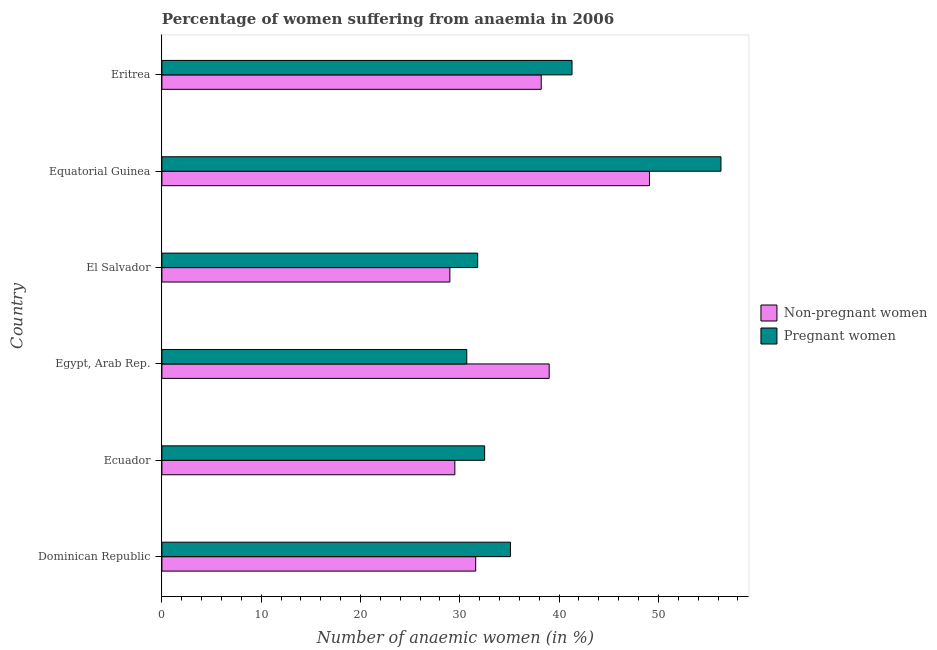How many groups of bars are there?
Provide a short and direct response. 6. How many bars are there on the 4th tick from the top?
Provide a succinct answer. 2. What is the label of the 4th group of bars from the top?
Give a very brief answer. Egypt, Arab Rep. What is the percentage of pregnant anaemic women in Eritrea?
Your response must be concise. 41.3. Across all countries, what is the maximum percentage of non-pregnant anaemic women?
Offer a terse response. 49.1. In which country was the percentage of pregnant anaemic women maximum?
Your answer should be very brief. Equatorial Guinea. In which country was the percentage of pregnant anaemic women minimum?
Provide a short and direct response. Egypt, Arab Rep. What is the total percentage of pregnant anaemic women in the graph?
Ensure brevity in your answer.  227.7. What is the difference between the percentage of pregnant anaemic women in Dominican Republic and that in Egypt, Arab Rep.?
Make the answer very short. 4.4. What is the difference between the percentage of pregnant anaemic women in Ecuador and the percentage of non-pregnant anaemic women in Dominican Republic?
Offer a very short reply. 0.9. What is the average percentage of pregnant anaemic women per country?
Ensure brevity in your answer.  37.95. In how many countries, is the percentage of non-pregnant anaemic women greater than 20 %?
Provide a succinct answer. 6. What is the ratio of the percentage of non-pregnant anaemic women in Ecuador to that in Egypt, Arab Rep.?
Your answer should be very brief. 0.76. Is the percentage of non-pregnant anaemic women in Equatorial Guinea less than that in Eritrea?
Provide a succinct answer. No. Is the difference between the percentage of non-pregnant anaemic women in Egypt, Arab Rep. and Eritrea greater than the difference between the percentage of pregnant anaemic women in Egypt, Arab Rep. and Eritrea?
Provide a succinct answer. Yes. What is the difference between the highest and the second highest percentage of non-pregnant anaemic women?
Provide a succinct answer. 10.1. What is the difference between the highest and the lowest percentage of pregnant anaemic women?
Make the answer very short. 25.6. In how many countries, is the percentage of pregnant anaemic women greater than the average percentage of pregnant anaemic women taken over all countries?
Offer a very short reply. 2. Is the sum of the percentage of pregnant anaemic women in Egypt, Arab Rep. and Equatorial Guinea greater than the maximum percentage of non-pregnant anaemic women across all countries?
Offer a very short reply. Yes. What does the 1st bar from the top in Egypt, Arab Rep. represents?
Provide a short and direct response. Pregnant women. What does the 1st bar from the bottom in El Salvador represents?
Your response must be concise. Non-pregnant women. How many countries are there in the graph?
Provide a short and direct response. 6. What is the difference between two consecutive major ticks on the X-axis?
Your response must be concise. 10. Does the graph contain any zero values?
Provide a short and direct response. No. Does the graph contain grids?
Give a very brief answer. No. What is the title of the graph?
Offer a terse response. Percentage of women suffering from anaemia in 2006. Does "Health Care" appear as one of the legend labels in the graph?
Keep it short and to the point. No. What is the label or title of the X-axis?
Offer a terse response. Number of anaemic women (in %). What is the label or title of the Y-axis?
Your answer should be compact. Country. What is the Number of anaemic women (in %) in Non-pregnant women in Dominican Republic?
Provide a succinct answer. 31.6. What is the Number of anaemic women (in %) in Pregnant women in Dominican Republic?
Your answer should be very brief. 35.1. What is the Number of anaemic women (in %) of Non-pregnant women in Ecuador?
Make the answer very short. 29.5. What is the Number of anaemic women (in %) of Pregnant women in Ecuador?
Ensure brevity in your answer.  32.5. What is the Number of anaemic women (in %) of Pregnant women in Egypt, Arab Rep.?
Your answer should be very brief. 30.7. What is the Number of anaemic women (in %) in Pregnant women in El Salvador?
Provide a short and direct response. 31.8. What is the Number of anaemic women (in %) in Non-pregnant women in Equatorial Guinea?
Your answer should be compact. 49.1. What is the Number of anaemic women (in %) of Pregnant women in Equatorial Guinea?
Ensure brevity in your answer.  56.3. What is the Number of anaemic women (in %) of Non-pregnant women in Eritrea?
Offer a very short reply. 38.2. What is the Number of anaemic women (in %) of Pregnant women in Eritrea?
Offer a very short reply. 41.3. Across all countries, what is the maximum Number of anaemic women (in %) of Non-pregnant women?
Offer a very short reply. 49.1. Across all countries, what is the maximum Number of anaemic women (in %) in Pregnant women?
Offer a terse response. 56.3. Across all countries, what is the minimum Number of anaemic women (in %) in Pregnant women?
Ensure brevity in your answer.  30.7. What is the total Number of anaemic women (in %) in Non-pregnant women in the graph?
Offer a very short reply. 216.4. What is the total Number of anaemic women (in %) of Pregnant women in the graph?
Provide a succinct answer. 227.7. What is the difference between the Number of anaemic women (in %) of Pregnant women in Dominican Republic and that in Egypt, Arab Rep.?
Provide a succinct answer. 4.4. What is the difference between the Number of anaemic women (in %) of Non-pregnant women in Dominican Republic and that in Equatorial Guinea?
Your answer should be very brief. -17.5. What is the difference between the Number of anaemic women (in %) in Pregnant women in Dominican Republic and that in Equatorial Guinea?
Keep it short and to the point. -21.2. What is the difference between the Number of anaemic women (in %) of Pregnant women in Dominican Republic and that in Eritrea?
Keep it short and to the point. -6.2. What is the difference between the Number of anaemic women (in %) of Non-pregnant women in Ecuador and that in El Salvador?
Offer a very short reply. 0.5. What is the difference between the Number of anaemic women (in %) of Pregnant women in Ecuador and that in El Salvador?
Give a very brief answer. 0.7. What is the difference between the Number of anaemic women (in %) in Non-pregnant women in Ecuador and that in Equatorial Guinea?
Provide a succinct answer. -19.6. What is the difference between the Number of anaemic women (in %) of Pregnant women in Ecuador and that in Equatorial Guinea?
Keep it short and to the point. -23.8. What is the difference between the Number of anaemic women (in %) of Non-pregnant women in Ecuador and that in Eritrea?
Your response must be concise. -8.7. What is the difference between the Number of anaemic women (in %) of Pregnant women in Ecuador and that in Eritrea?
Offer a terse response. -8.8. What is the difference between the Number of anaemic women (in %) of Non-pregnant women in Egypt, Arab Rep. and that in El Salvador?
Make the answer very short. 10. What is the difference between the Number of anaemic women (in %) in Pregnant women in Egypt, Arab Rep. and that in Equatorial Guinea?
Give a very brief answer. -25.6. What is the difference between the Number of anaemic women (in %) of Non-pregnant women in Egypt, Arab Rep. and that in Eritrea?
Give a very brief answer. 0.8. What is the difference between the Number of anaemic women (in %) of Non-pregnant women in El Salvador and that in Equatorial Guinea?
Offer a terse response. -20.1. What is the difference between the Number of anaemic women (in %) of Pregnant women in El Salvador and that in Equatorial Guinea?
Make the answer very short. -24.5. What is the difference between the Number of anaemic women (in %) of Non-pregnant women in El Salvador and that in Eritrea?
Keep it short and to the point. -9.2. What is the difference between the Number of anaemic women (in %) of Pregnant women in El Salvador and that in Eritrea?
Your answer should be very brief. -9.5. What is the difference between the Number of anaemic women (in %) of Pregnant women in Equatorial Guinea and that in Eritrea?
Make the answer very short. 15. What is the difference between the Number of anaemic women (in %) of Non-pregnant women in Dominican Republic and the Number of anaemic women (in %) of Pregnant women in Egypt, Arab Rep.?
Your response must be concise. 0.9. What is the difference between the Number of anaemic women (in %) in Non-pregnant women in Dominican Republic and the Number of anaemic women (in %) in Pregnant women in El Salvador?
Ensure brevity in your answer.  -0.2. What is the difference between the Number of anaemic women (in %) of Non-pregnant women in Dominican Republic and the Number of anaemic women (in %) of Pregnant women in Equatorial Guinea?
Offer a terse response. -24.7. What is the difference between the Number of anaemic women (in %) in Non-pregnant women in Ecuador and the Number of anaemic women (in %) in Pregnant women in Egypt, Arab Rep.?
Your response must be concise. -1.2. What is the difference between the Number of anaemic women (in %) of Non-pregnant women in Ecuador and the Number of anaemic women (in %) of Pregnant women in Equatorial Guinea?
Your answer should be compact. -26.8. What is the difference between the Number of anaemic women (in %) in Non-pregnant women in Egypt, Arab Rep. and the Number of anaemic women (in %) in Pregnant women in El Salvador?
Offer a very short reply. 7.2. What is the difference between the Number of anaemic women (in %) in Non-pregnant women in Egypt, Arab Rep. and the Number of anaemic women (in %) in Pregnant women in Equatorial Guinea?
Provide a short and direct response. -17.3. What is the difference between the Number of anaemic women (in %) in Non-pregnant women in Egypt, Arab Rep. and the Number of anaemic women (in %) in Pregnant women in Eritrea?
Provide a succinct answer. -2.3. What is the difference between the Number of anaemic women (in %) of Non-pregnant women in El Salvador and the Number of anaemic women (in %) of Pregnant women in Equatorial Guinea?
Your answer should be compact. -27.3. What is the average Number of anaemic women (in %) in Non-pregnant women per country?
Keep it short and to the point. 36.07. What is the average Number of anaemic women (in %) of Pregnant women per country?
Your answer should be very brief. 37.95. What is the difference between the Number of anaemic women (in %) in Non-pregnant women and Number of anaemic women (in %) in Pregnant women in Dominican Republic?
Keep it short and to the point. -3.5. What is the difference between the Number of anaemic women (in %) in Non-pregnant women and Number of anaemic women (in %) in Pregnant women in El Salvador?
Offer a terse response. -2.8. What is the difference between the Number of anaemic women (in %) in Non-pregnant women and Number of anaemic women (in %) in Pregnant women in Equatorial Guinea?
Your response must be concise. -7.2. What is the difference between the Number of anaemic women (in %) of Non-pregnant women and Number of anaemic women (in %) of Pregnant women in Eritrea?
Your response must be concise. -3.1. What is the ratio of the Number of anaemic women (in %) in Non-pregnant women in Dominican Republic to that in Ecuador?
Provide a succinct answer. 1.07. What is the ratio of the Number of anaemic women (in %) in Pregnant women in Dominican Republic to that in Ecuador?
Offer a terse response. 1.08. What is the ratio of the Number of anaemic women (in %) in Non-pregnant women in Dominican Republic to that in Egypt, Arab Rep.?
Offer a very short reply. 0.81. What is the ratio of the Number of anaemic women (in %) in Pregnant women in Dominican Republic to that in Egypt, Arab Rep.?
Offer a terse response. 1.14. What is the ratio of the Number of anaemic women (in %) of Non-pregnant women in Dominican Republic to that in El Salvador?
Your response must be concise. 1.09. What is the ratio of the Number of anaemic women (in %) in Pregnant women in Dominican Republic to that in El Salvador?
Your answer should be very brief. 1.1. What is the ratio of the Number of anaemic women (in %) of Non-pregnant women in Dominican Republic to that in Equatorial Guinea?
Your response must be concise. 0.64. What is the ratio of the Number of anaemic women (in %) in Pregnant women in Dominican Republic to that in Equatorial Guinea?
Your response must be concise. 0.62. What is the ratio of the Number of anaemic women (in %) of Non-pregnant women in Dominican Republic to that in Eritrea?
Give a very brief answer. 0.83. What is the ratio of the Number of anaemic women (in %) in Pregnant women in Dominican Republic to that in Eritrea?
Your answer should be very brief. 0.85. What is the ratio of the Number of anaemic women (in %) in Non-pregnant women in Ecuador to that in Egypt, Arab Rep.?
Offer a very short reply. 0.76. What is the ratio of the Number of anaemic women (in %) in Pregnant women in Ecuador to that in Egypt, Arab Rep.?
Ensure brevity in your answer.  1.06. What is the ratio of the Number of anaemic women (in %) of Non-pregnant women in Ecuador to that in El Salvador?
Offer a very short reply. 1.02. What is the ratio of the Number of anaemic women (in %) in Non-pregnant women in Ecuador to that in Equatorial Guinea?
Ensure brevity in your answer.  0.6. What is the ratio of the Number of anaemic women (in %) in Pregnant women in Ecuador to that in Equatorial Guinea?
Keep it short and to the point. 0.58. What is the ratio of the Number of anaemic women (in %) in Non-pregnant women in Ecuador to that in Eritrea?
Offer a very short reply. 0.77. What is the ratio of the Number of anaemic women (in %) of Pregnant women in Ecuador to that in Eritrea?
Offer a very short reply. 0.79. What is the ratio of the Number of anaemic women (in %) of Non-pregnant women in Egypt, Arab Rep. to that in El Salvador?
Provide a succinct answer. 1.34. What is the ratio of the Number of anaemic women (in %) of Pregnant women in Egypt, Arab Rep. to that in El Salvador?
Make the answer very short. 0.97. What is the ratio of the Number of anaemic women (in %) in Non-pregnant women in Egypt, Arab Rep. to that in Equatorial Guinea?
Offer a very short reply. 0.79. What is the ratio of the Number of anaemic women (in %) in Pregnant women in Egypt, Arab Rep. to that in Equatorial Guinea?
Offer a very short reply. 0.55. What is the ratio of the Number of anaemic women (in %) in Non-pregnant women in Egypt, Arab Rep. to that in Eritrea?
Provide a short and direct response. 1.02. What is the ratio of the Number of anaemic women (in %) in Pregnant women in Egypt, Arab Rep. to that in Eritrea?
Ensure brevity in your answer.  0.74. What is the ratio of the Number of anaemic women (in %) in Non-pregnant women in El Salvador to that in Equatorial Guinea?
Your answer should be very brief. 0.59. What is the ratio of the Number of anaemic women (in %) in Pregnant women in El Salvador to that in Equatorial Guinea?
Offer a terse response. 0.56. What is the ratio of the Number of anaemic women (in %) of Non-pregnant women in El Salvador to that in Eritrea?
Your answer should be very brief. 0.76. What is the ratio of the Number of anaemic women (in %) of Pregnant women in El Salvador to that in Eritrea?
Your answer should be very brief. 0.77. What is the ratio of the Number of anaemic women (in %) of Non-pregnant women in Equatorial Guinea to that in Eritrea?
Provide a succinct answer. 1.29. What is the ratio of the Number of anaemic women (in %) of Pregnant women in Equatorial Guinea to that in Eritrea?
Your response must be concise. 1.36. What is the difference between the highest and the second highest Number of anaemic women (in %) of Non-pregnant women?
Your answer should be compact. 10.1. What is the difference between the highest and the lowest Number of anaemic women (in %) in Non-pregnant women?
Your answer should be compact. 20.1. What is the difference between the highest and the lowest Number of anaemic women (in %) of Pregnant women?
Make the answer very short. 25.6. 